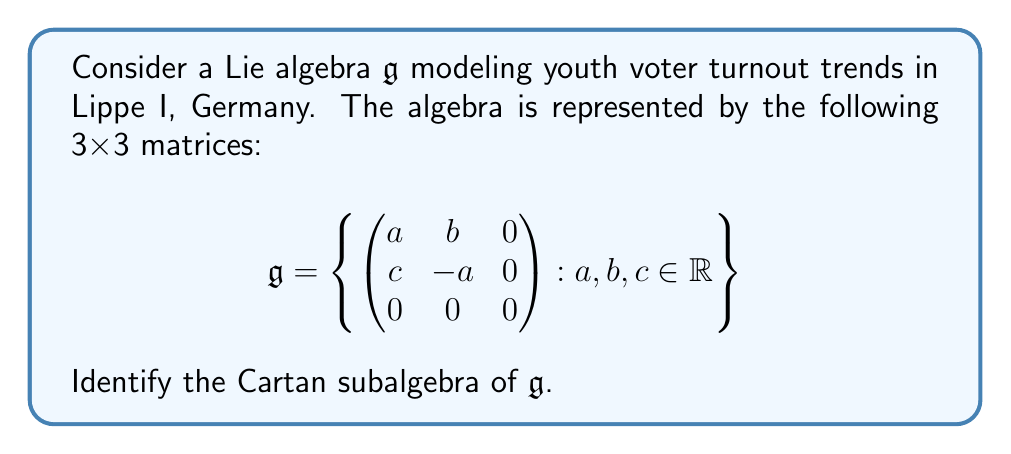Show me your answer to this math problem. To identify the Cartan subalgebra of $\mathfrak{g}$, we need to follow these steps:

1) Recall that a Cartan subalgebra is a maximal abelian subalgebra consisting of semisimple elements.

2) In this case, we need to find the largest subalgebra of $\mathfrak{g}$ whose elements commute with each other and are diagonalizable.

3) Let's consider a general element of $\mathfrak{g}$:

   $$X = \begin{pmatrix} 
   a & b & 0 \\
   c & -a & 0 \\
   0 & 0 & 0
   \end{pmatrix}$$

4) For $X$ to be semisimple, it must be diagonalizable. The characteristic polynomial of $X$ is:

   $$p(t) = t(t^2 - a^2 - bc)$$

5) For $X$ to be diagonalizable, we need $bc = -a^2$. The simplest way to ensure this is to have $b = c = 0$.

6) Now, let's consider two elements of this form:

   $$X_1 = \begin{pmatrix} 
   a_1 & 0 & 0 \\
   0 & -a_1 & 0 \\
   0 & 0 & 0
   \end{pmatrix}, 
   X_2 = \begin{pmatrix} 
   a_2 & 0 & 0 \\
   0 & -a_2 & 0 \\
   0 & 0 & 0
   \end{pmatrix}$$

7) These elements commute:

   $$[X_1, X_2] = X_1X_2 - X_2X_1 = 0$$

8) Therefore, the Cartan subalgebra $\mathfrak{h}$ of $\mathfrak{g}$ is:

   $$\mathfrak{h} = \left\{ \begin{pmatrix} 
   a & 0 & 0 \\
   0 & -a & 0 \\
   0 & 0 & 0
   \end{pmatrix} : a \in \mathbb{R} \right\}$$

This subalgebra is maximal abelian and consists of semisimple elements, thus satisfying the definition of a Cartan subalgebra.
Answer: The Cartan subalgebra of $\mathfrak{g}$ is:

$$\mathfrak{h} = \left\{ \begin{pmatrix} 
a & 0 & 0 \\
0 & -a & 0 \\
0 & 0 & 0
\end{pmatrix} : a \in \mathbb{R} \right\}$$ 